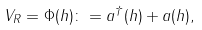Convert formula to latex. <formula><loc_0><loc_0><loc_500><loc_500>V _ { R } = \Phi ( h ) \colon = a ^ { \dagger } ( h ) + a ( h ) ,</formula> 